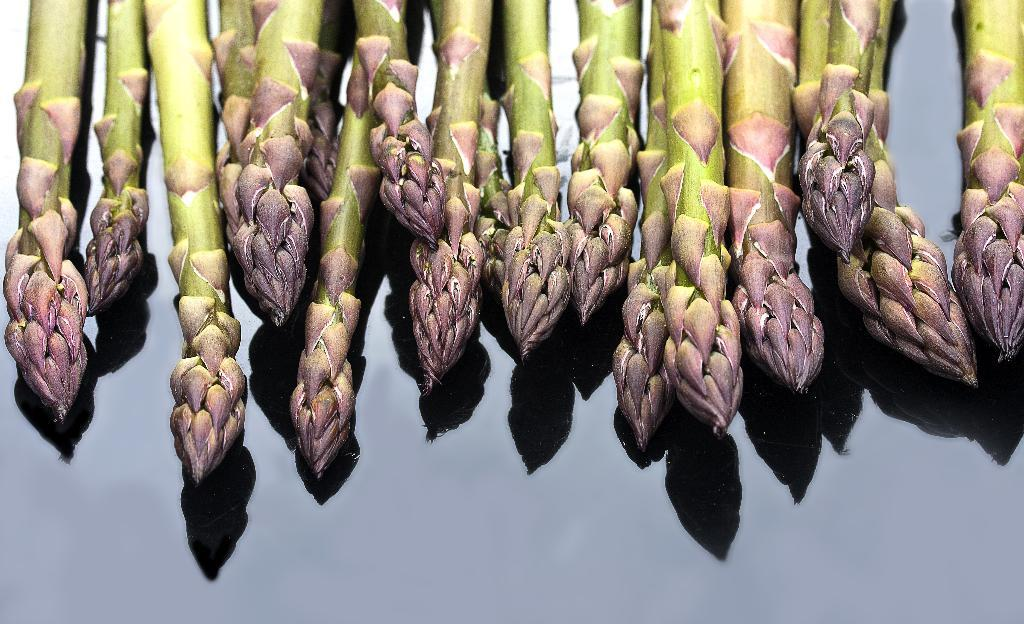What is the main subject of the image? The main subject of the image is a green stick with many buds on it. What can be seen at the bottom of the image? There is water visible at the bottom of the image. How much profit can be made from the buds in the image? There is no information about profit or any financial aspect in the image, as it only shows a green stick with buds and water. 